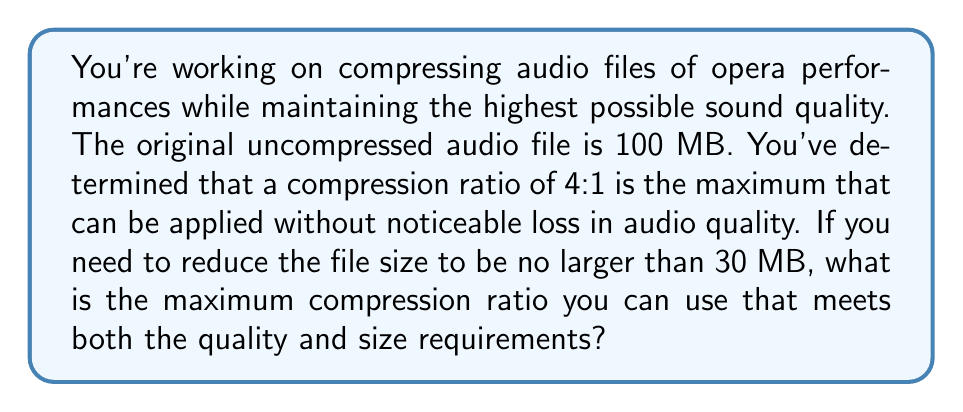Could you help me with this problem? Let's approach this step-by-step:

1) First, let's define our variables:
   $x$ = compression ratio we're looking for
   
2) We know that the original file size is 100 MB and we need the compressed file to be no larger than 30 MB. We can express this as:

   $$\frac{100}{x} \leq 30$$

3) Solving for $x$:
   $$x \geq \frac{100}{30} \approx 3.33$$

4) This means we need a compression ratio of at least 3.33:1 to meet the size requirement.

5) However, we also need to consider the quality requirement. We're told that 4:1 is the maximum compression ratio that maintains acceptable quality.

6) Therefore, our compression ratio $x$ must satisfy both conditions:
   $$3.33 \leq x \leq 4$$

7) Since we want the maximum compression ratio that satisfies both conditions, we choose the largest value in this range that doesn't exceed 4.

8) The largest value that satisfies both conditions is 3.33:1 (rounded to two decimal places).
Answer: The maximum compression ratio that meets both the quality and size requirements is 3.33:1. 